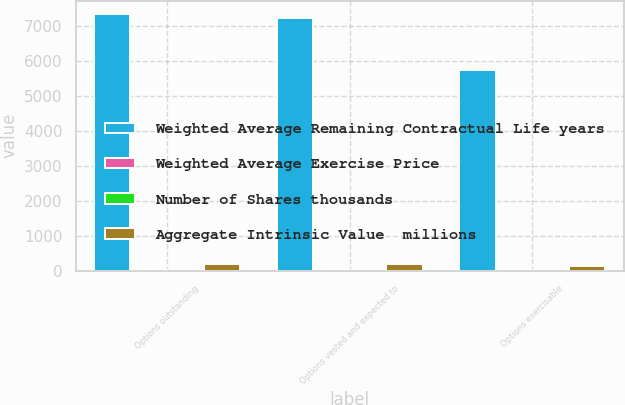Convert chart. <chart><loc_0><loc_0><loc_500><loc_500><stacked_bar_chart><ecel><fcel>Options outstanding<fcel>Options vested and expected to<fcel>Options exercisable<nl><fcel>Weighted Average Remaining Contractual Life years<fcel>7359<fcel>7242<fcel>5752<nl><fcel>Weighted Average Exercise Price<fcel>29.93<fcel>30.05<fcel>31.28<nl><fcel>Number of Shares thousands<fcel>3.22<fcel>3.18<fcel>2.65<nl><fcel>Aggregate Intrinsic Value  millions<fcel>197.6<fcel>193.6<fcel>146.7<nl></chart> 